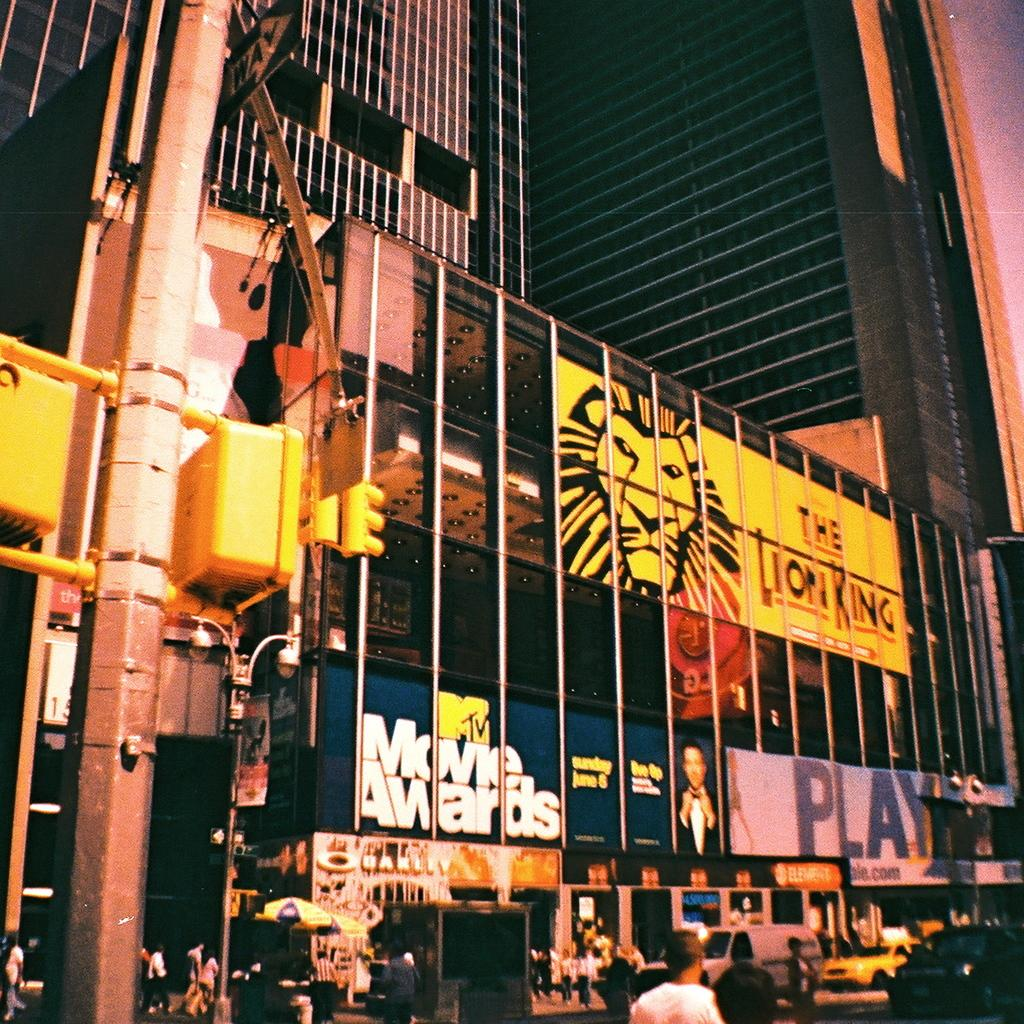<image>
Offer a succinct explanation of the picture presented. A giant add for the Lion King covers the side  of a building. 